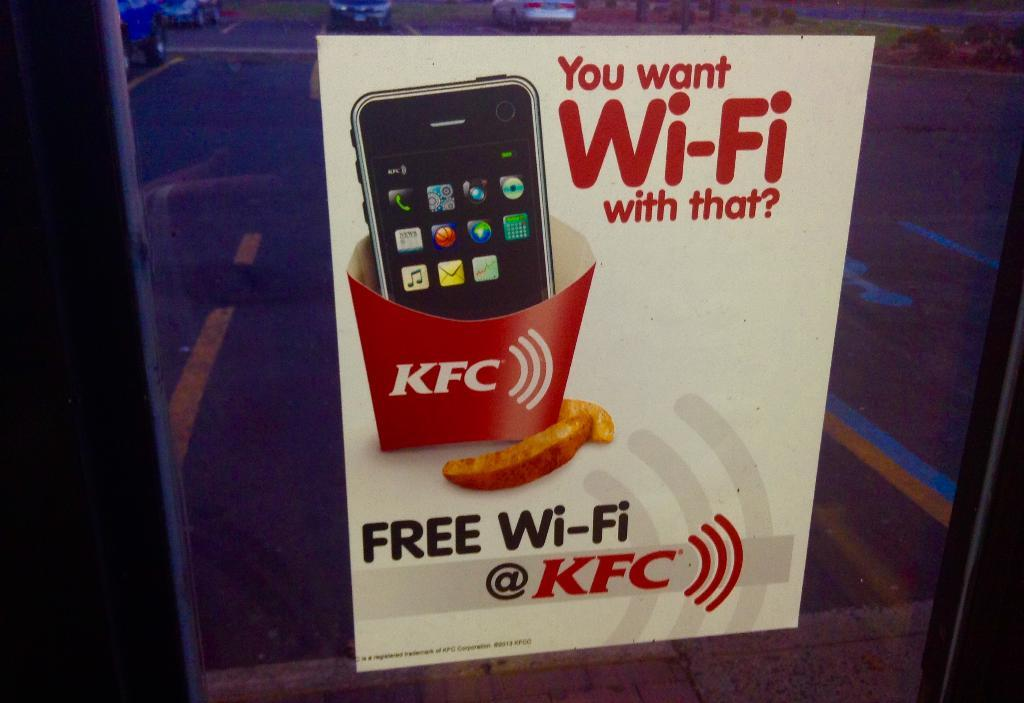Provide a one-sentence caption for the provided image. A sign advertising free Wi-Fi at KFC restaurants. 